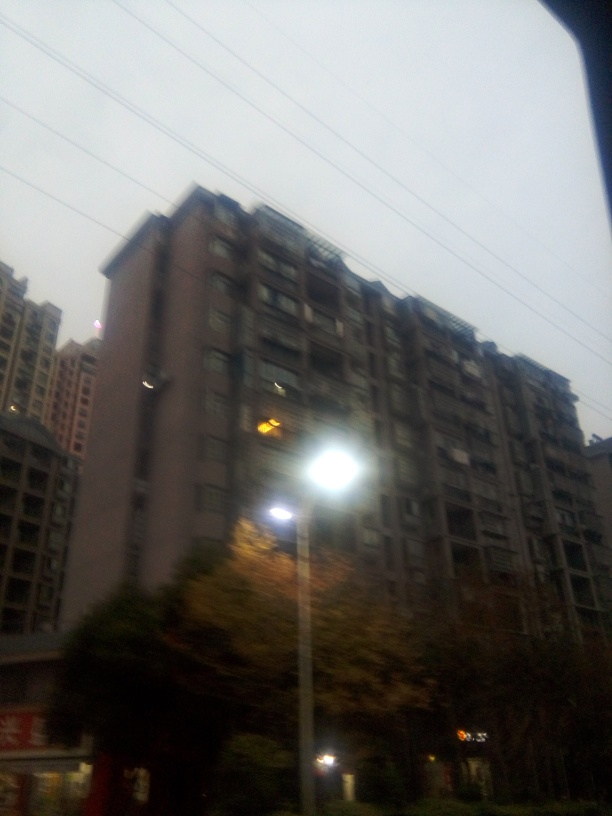How would you describe the light source area in this image?
A. Dark
B. Overexposed with ghosting
C. Properly lit
D. Perfectly exposed
Answer with the option's letter from the given choices directly. The light source area in this image is best described as overexposed with ghosting, which means that the light is too intense compared to the rest of the scene, causing a loss in detail and creating a 'ghost-like' halo effect around the light. This typically occurs when the camera's sensor cannot handle the range of luminance without sacrificing some detail in the brighter areas. 